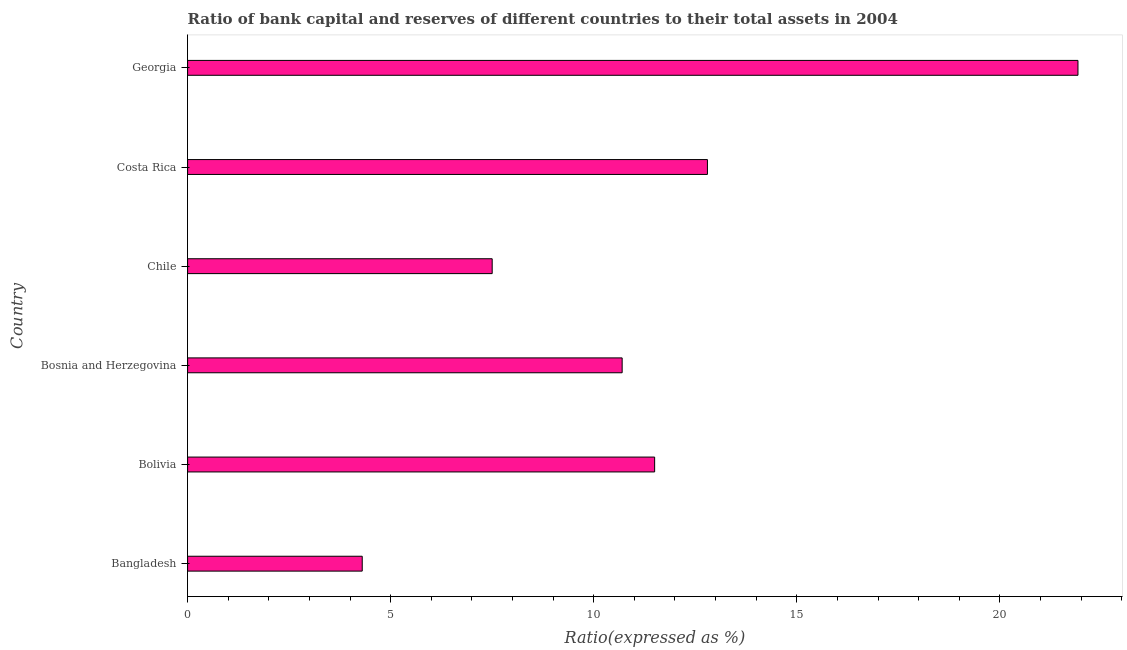What is the title of the graph?
Your answer should be very brief. Ratio of bank capital and reserves of different countries to their total assets in 2004. What is the label or title of the X-axis?
Your answer should be very brief. Ratio(expressed as %). What is the bank capital to assets ratio in Bangladesh?
Provide a succinct answer. 4.3. Across all countries, what is the maximum bank capital to assets ratio?
Make the answer very short. 21.92. Across all countries, what is the minimum bank capital to assets ratio?
Offer a very short reply. 4.3. In which country was the bank capital to assets ratio maximum?
Your response must be concise. Georgia. What is the sum of the bank capital to assets ratio?
Your response must be concise. 68.72. What is the difference between the bank capital to assets ratio in Bolivia and Costa Rica?
Offer a terse response. -1.3. What is the average bank capital to assets ratio per country?
Your response must be concise. 11.45. What is the ratio of the bank capital to assets ratio in Bangladesh to that in Chile?
Make the answer very short. 0.57. What is the difference between the highest and the second highest bank capital to assets ratio?
Your answer should be very brief. 9.12. Is the sum of the bank capital to assets ratio in Bangladesh and Bolivia greater than the maximum bank capital to assets ratio across all countries?
Your answer should be compact. No. What is the difference between the highest and the lowest bank capital to assets ratio?
Offer a terse response. 17.62. In how many countries, is the bank capital to assets ratio greater than the average bank capital to assets ratio taken over all countries?
Offer a terse response. 3. How many countries are there in the graph?
Offer a very short reply. 6. What is the difference between two consecutive major ticks on the X-axis?
Your answer should be compact. 5. What is the Ratio(expressed as %) of Bosnia and Herzegovina?
Your response must be concise. 10.7. What is the Ratio(expressed as %) of Chile?
Ensure brevity in your answer.  7.5. What is the Ratio(expressed as %) of Georgia?
Your answer should be very brief. 21.92. What is the difference between the Ratio(expressed as %) in Bangladesh and Bolivia?
Ensure brevity in your answer.  -7.2. What is the difference between the Ratio(expressed as %) in Bangladesh and Bosnia and Herzegovina?
Offer a terse response. -6.4. What is the difference between the Ratio(expressed as %) in Bangladesh and Chile?
Give a very brief answer. -3.2. What is the difference between the Ratio(expressed as %) in Bangladesh and Georgia?
Make the answer very short. -17.62. What is the difference between the Ratio(expressed as %) in Bolivia and Bosnia and Herzegovina?
Make the answer very short. 0.8. What is the difference between the Ratio(expressed as %) in Bolivia and Chile?
Your answer should be compact. 4. What is the difference between the Ratio(expressed as %) in Bolivia and Costa Rica?
Provide a succinct answer. -1.3. What is the difference between the Ratio(expressed as %) in Bolivia and Georgia?
Give a very brief answer. -10.42. What is the difference between the Ratio(expressed as %) in Bosnia and Herzegovina and Costa Rica?
Ensure brevity in your answer.  -2.1. What is the difference between the Ratio(expressed as %) in Bosnia and Herzegovina and Georgia?
Offer a terse response. -11.22. What is the difference between the Ratio(expressed as %) in Chile and Costa Rica?
Give a very brief answer. -5.3. What is the difference between the Ratio(expressed as %) in Chile and Georgia?
Provide a short and direct response. -14.42. What is the difference between the Ratio(expressed as %) in Costa Rica and Georgia?
Ensure brevity in your answer.  -9.12. What is the ratio of the Ratio(expressed as %) in Bangladesh to that in Bolivia?
Provide a short and direct response. 0.37. What is the ratio of the Ratio(expressed as %) in Bangladesh to that in Bosnia and Herzegovina?
Offer a terse response. 0.4. What is the ratio of the Ratio(expressed as %) in Bangladesh to that in Chile?
Offer a terse response. 0.57. What is the ratio of the Ratio(expressed as %) in Bangladesh to that in Costa Rica?
Make the answer very short. 0.34. What is the ratio of the Ratio(expressed as %) in Bangladesh to that in Georgia?
Offer a very short reply. 0.2. What is the ratio of the Ratio(expressed as %) in Bolivia to that in Bosnia and Herzegovina?
Your answer should be compact. 1.07. What is the ratio of the Ratio(expressed as %) in Bolivia to that in Chile?
Your answer should be very brief. 1.53. What is the ratio of the Ratio(expressed as %) in Bolivia to that in Costa Rica?
Ensure brevity in your answer.  0.9. What is the ratio of the Ratio(expressed as %) in Bolivia to that in Georgia?
Provide a short and direct response. 0.53. What is the ratio of the Ratio(expressed as %) in Bosnia and Herzegovina to that in Chile?
Provide a short and direct response. 1.43. What is the ratio of the Ratio(expressed as %) in Bosnia and Herzegovina to that in Costa Rica?
Offer a very short reply. 0.84. What is the ratio of the Ratio(expressed as %) in Bosnia and Herzegovina to that in Georgia?
Keep it short and to the point. 0.49. What is the ratio of the Ratio(expressed as %) in Chile to that in Costa Rica?
Make the answer very short. 0.59. What is the ratio of the Ratio(expressed as %) in Chile to that in Georgia?
Keep it short and to the point. 0.34. What is the ratio of the Ratio(expressed as %) in Costa Rica to that in Georgia?
Offer a very short reply. 0.58. 